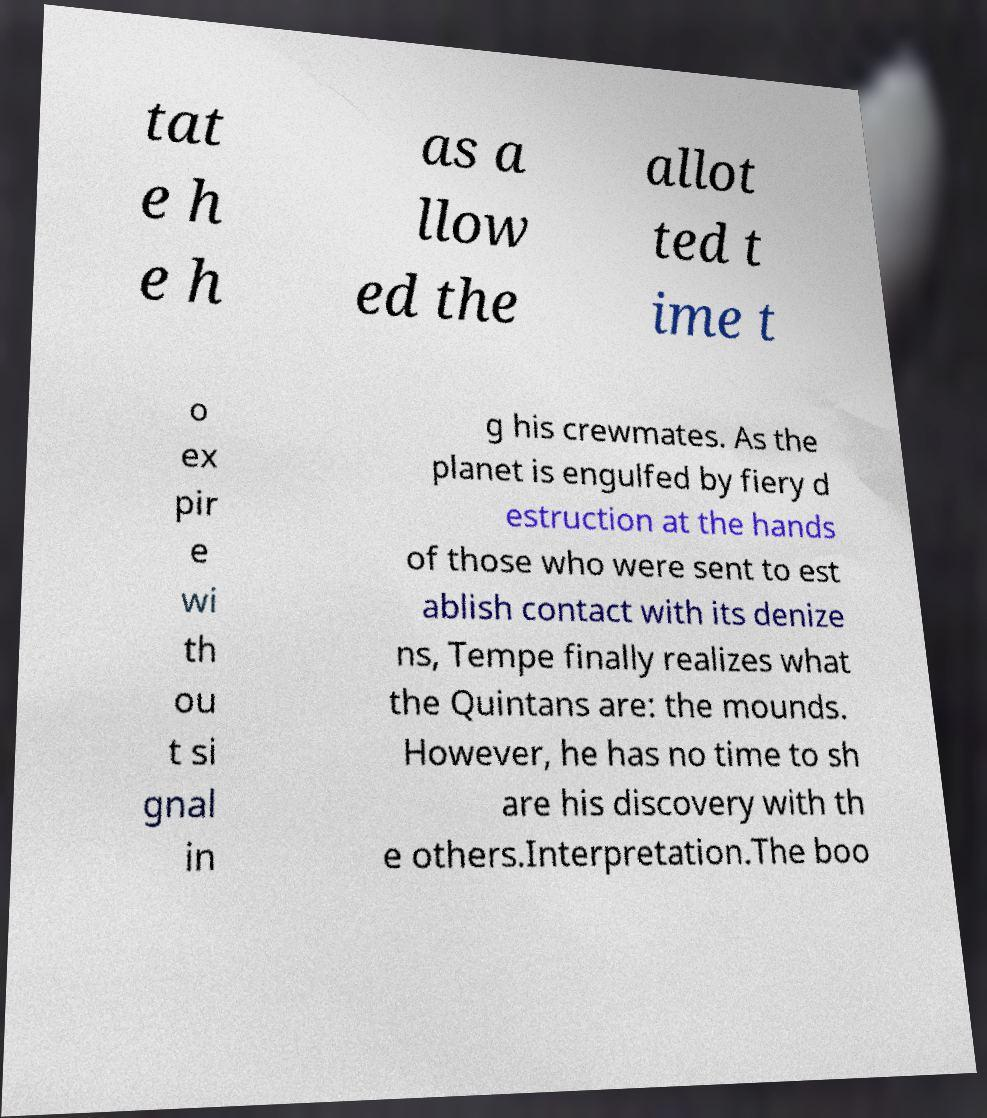Please read and relay the text visible in this image. What does it say? tat e h e h as a llow ed the allot ted t ime t o ex pir e wi th ou t si gnal in g his crewmates. As the planet is engulfed by fiery d estruction at the hands of those who were sent to est ablish contact with its denize ns, Tempe finally realizes what the Quintans are: the mounds. However, he has no time to sh are his discovery with th e others.Interpretation.The boo 